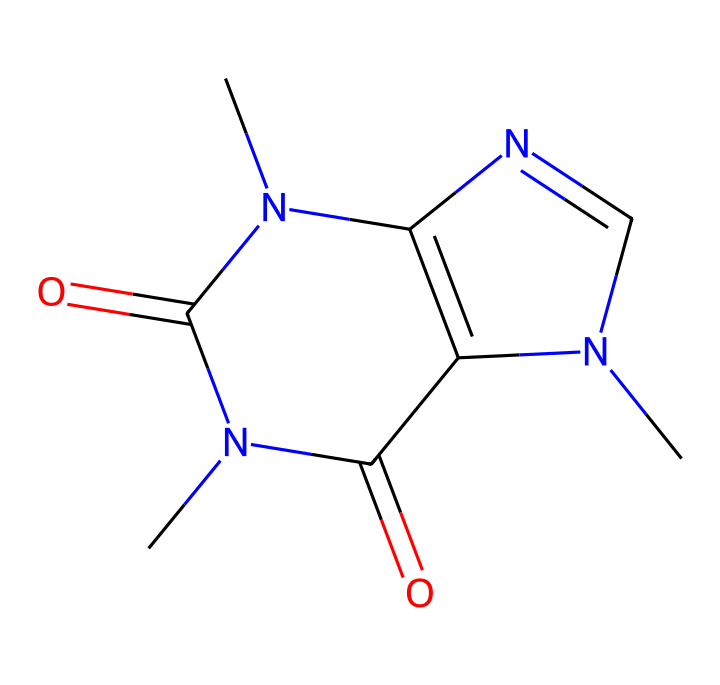What is the molecular formula of this compound? To derive the molecular formula from the SMILES representation, analyze the atoms present. There are two carbonyl groups (C=O), and nitrogen atoms are seen, indicating the presence of nitrogen in the composition. Counting the atoms from the structure gives the formula C8H10N4O2.
Answer: C8H10N4O2 How many nitrogen atoms are in the structure? Analyzing the SMILES representation, there are four 'N' atoms visible, which indicates the total count.
Answer: 4 What type of compound is caffeine classified as? Caffeine, based on its nitrogen-containing structure and origin from natural sources like tea, is classified as an alkaloid. The presence of multiple nitrogen atoms is a hallmark of alkaloids.
Answer: alkaloid How many rings are present in the structure? Inspecting the structure, two distinct ring systems can be identified. The presence of nitrogen in both cycles confirms the double ring composition.
Answer: 2 What functional groups are present in this compound? The SMILES representation shows carbonyl (C=O) functional groups, which are crucial for its inactivity and aroma. Furthermore, these groups also contribute to its chemical properties.
Answer: carbonyl What is the basic property that caffeine is known for? Caffeine is well known for its stimulating properties, which are influenced by its structural arrangement and the nitrogen atoms present, making it a psychoactive substance found in beverages.
Answer: stimulant 